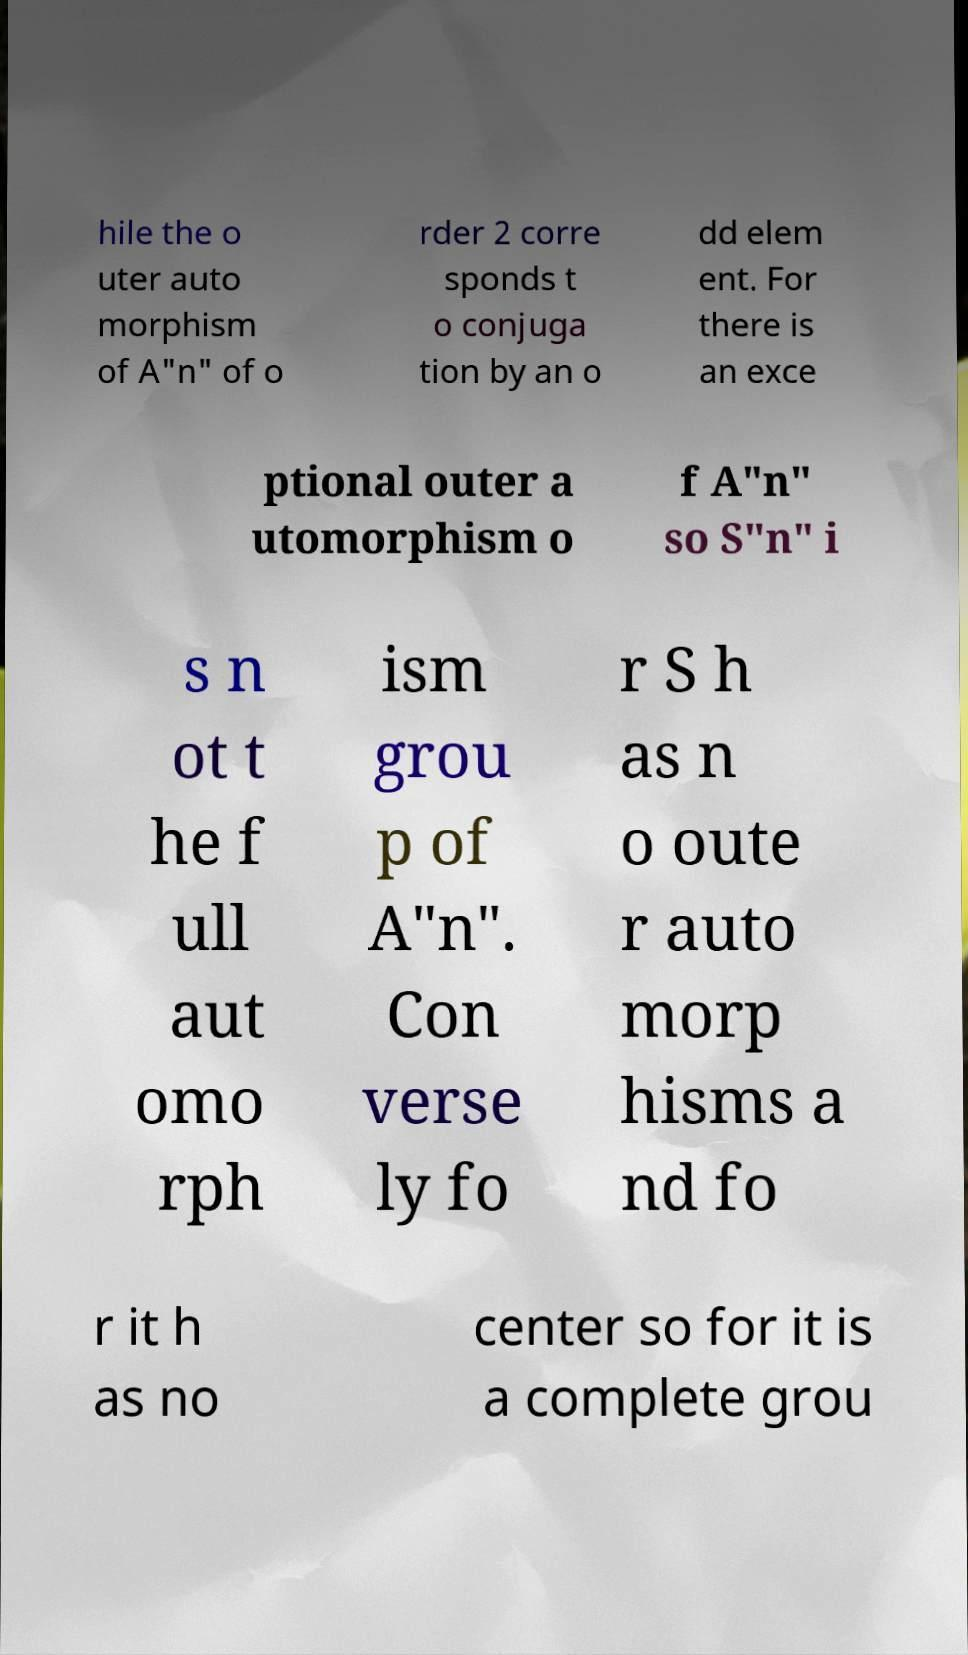For documentation purposes, I need the text within this image transcribed. Could you provide that? hile the o uter auto morphism of A"n" of o rder 2 corre sponds t o conjuga tion by an o dd elem ent. For there is an exce ptional outer a utomorphism o f A"n" so S"n" i s n ot t he f ull aut omo rph ism grou p of A"n". Con verse ly fo r S h as n o oute r auto morp hisms a nd fo r it h as no center so for it is a complete grou 